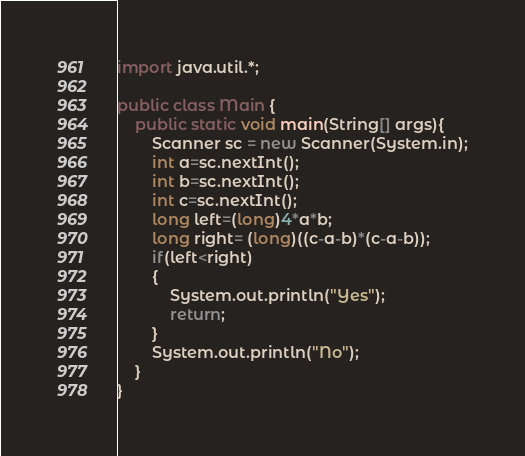Convert code to text. <code><loc_0><loc_0><loc_500><loc_500><_Java_>import java.util.*;

public class Main {
    public static void main(String[] args){
        Scanner sc = new Scanner(System.in);
        int a=sc.nextInt();
        int b=sc.nextInt();
        int c=sc.nextInt();
        long left=(long)4*a*b;
        long right= (long)((c-a-b)*(c-a-b));
        if(left<right)
        {
            System.out.println("Yes");
            return;
        }
        System.out.println("No");
    }
}</code> 